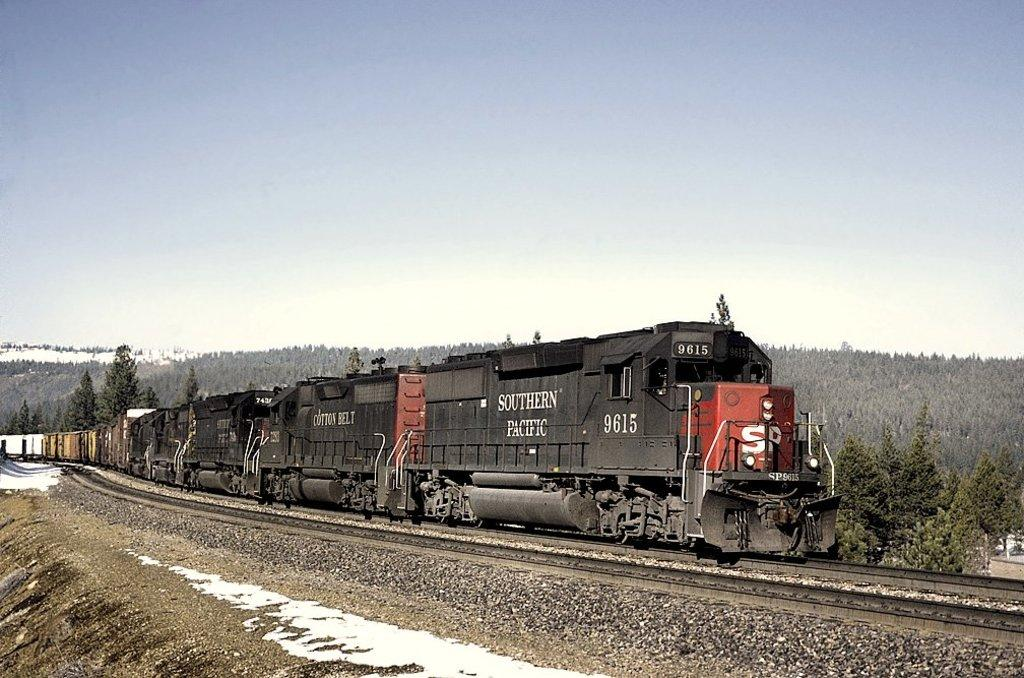What is the main subject of the image? The main subject of the image is a train. What is the train's position in relation to the track? The train is on a track. What can be seen in the background of the image? There are three hills and the sky visible in the background of the image. What is the weather like in the image? The presence of snow at the bottom of the image suggests that it is a snowy environment. What type of committee can be seen meeting in the image? There is no committee present in the image; it features a train on a track with a snowy background. Can you tell me how many buckets are used to collect the snow in the image? There are no buckets present in the image; it only shows a train on a track with snow at the bottom. 